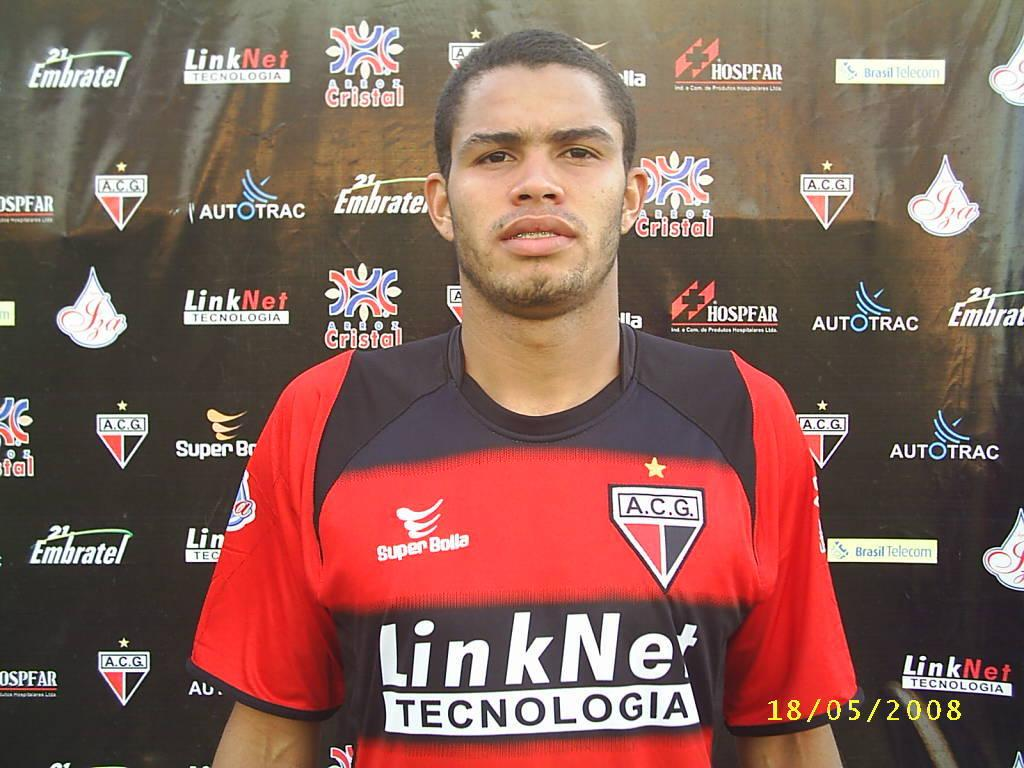<image>
Share a concise interpretation of the image provided. A player is pictured in front of a backdrop sponsored by many companies including LinkNet. 